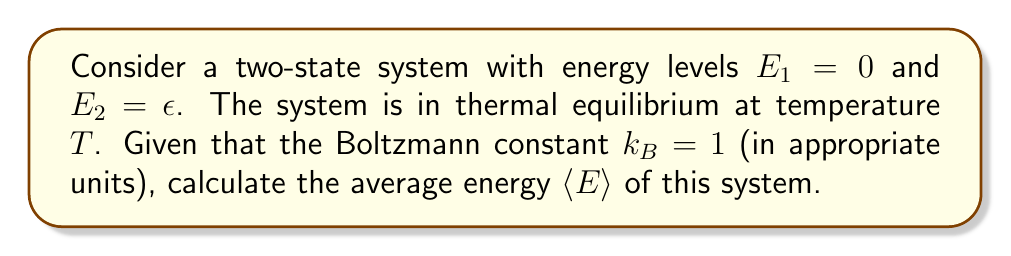Could you help me with this problem? Let's approach this step-by-step:

1) In a two-state system, we can use the partition function $Z$ to calculate the probabilities of each state:

   $Z = e^{-\beta E_1} + e^{-\beta E_2}$

   where $\beta = \frac{1}{k_BT} = \frac{1}{T}$ (since $k_B = 1$)

2) Substituting the given energy levels:

   $Z = e^{-\beta \cdot 0} + e^{-\beta \epsilon} = 1 + e^{-\beta \epsilon}$

3) The probability of each state is given by:

   $P_1 = \frac{e^{-\beta E_1}}{Z} = \frac{1}{1 + e^{-\beta \epsilon}}$

   $P_2 = \frac{e^{-\beta E_2}}{Z} = \frac{e^{-\beta \epsilon}}{1 + e^{-\beta \epsilon}}$

4) The average energy is calculated as:

   $\langle E \rangle = E_1 P_1 + E_2 P_2$

5) Substituting the values:

   $\langle E \rangle = 0 \cdot \frac{1}{1 + e^{-\beta \epsilon}} + \epsilon \cdot \frac{e^{-\beta \epsilon}}{1 + e^{-\beta \epsilon}}$

6) Simplifying:

   $\langle E \rangle = \frac{\epsilon e^{-\beta \epsilon}}{1 + e^{-\beta \epsilon}}$

7) This can be further simplified by dividing both numerator and denominator by $e^{-\beta \epsilon}$:

   $\langle E \rangle = \frac{\epsilon}{e^{\beta \epsilon} + 1}$

8) Recalling that $\beta = \frac{1}{T}$, we get our final expression:

   $\langle E \rangle = \frac{\epsilon}{e^{\epsilon/T} + 1}$
Answer: $\langle E \rangle = \frac{\epsilon}{e^{\epsilon/T} + 1}$ 